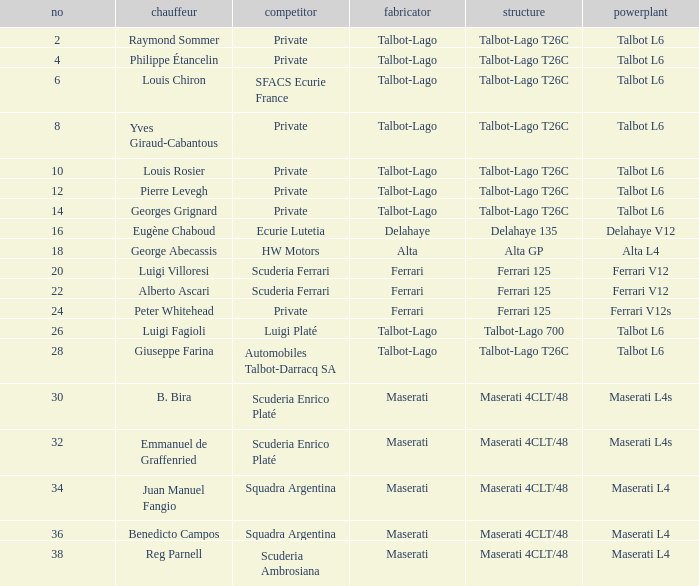Name the engine for ecurie lutetia Delahaye V12. 